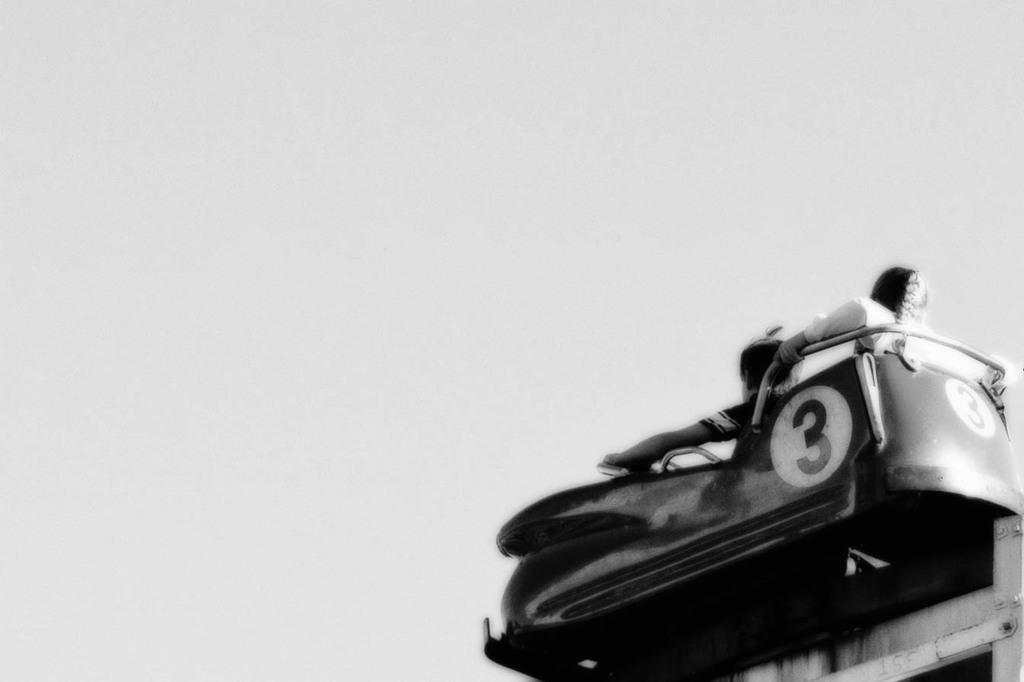What is the main subject of the image? There is a vehicle in the image. How many people are inside the vehicle? Two persons are sitting in the vehicle. What is the color scheme of the image? The image is in black and white. How many horses can be seen grazing near the vehicle in the image? There are no horses present in the image; it only features a vehicle and two people. What type of wren is perched on the hood of the vehicle in the image? There is no wren present in the image; it is a black and white image of a vehicle with two people inside. 